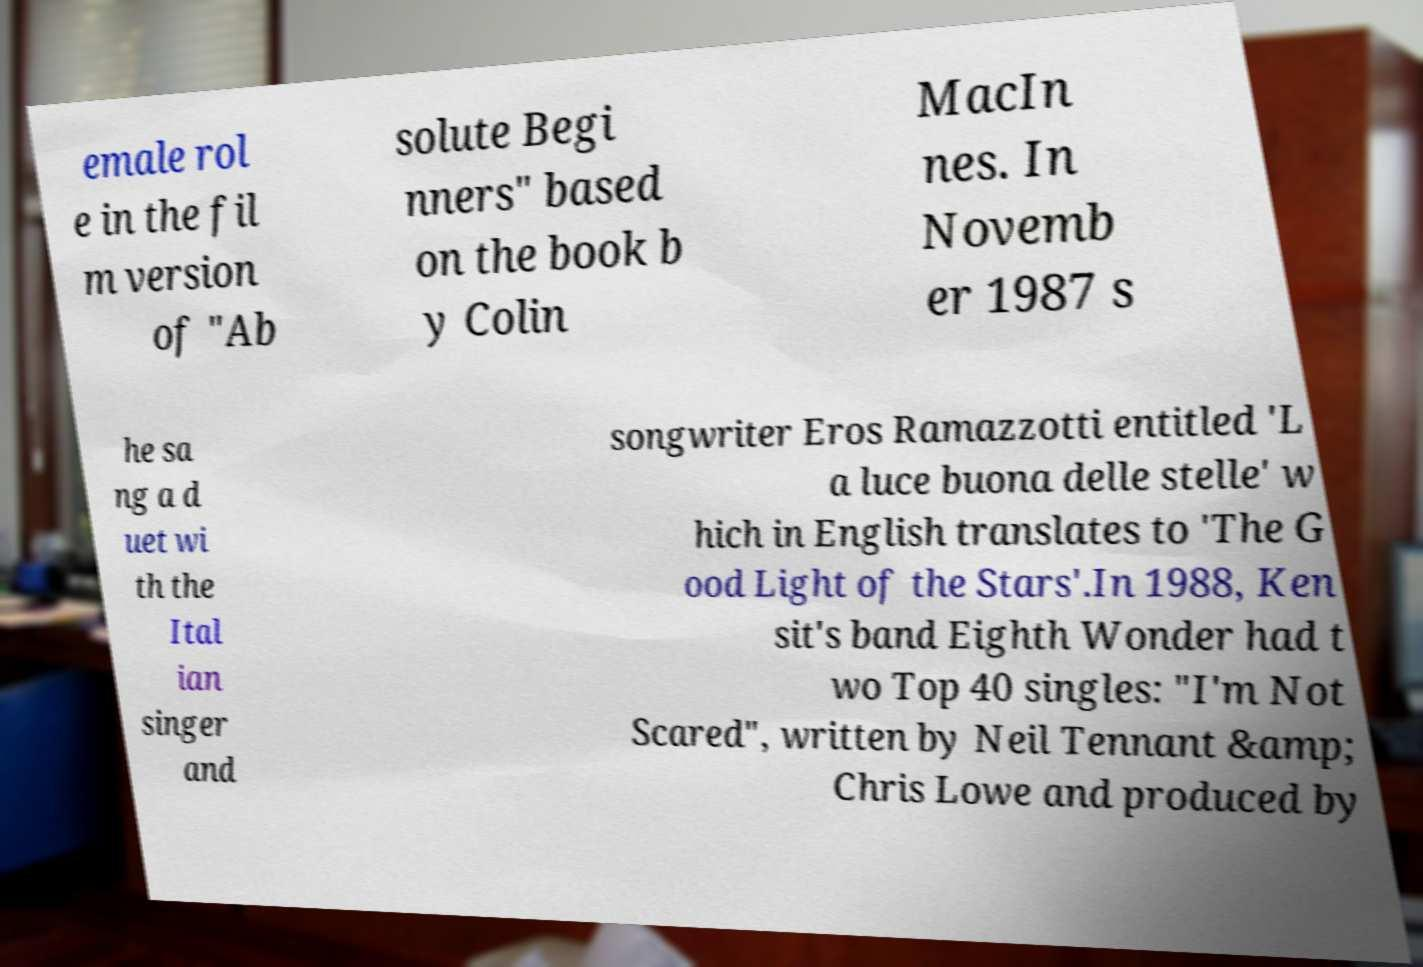I need the written content from this picture converted into text. Can you do that? emale rol e in the fil m version of "Ab solute Begi nners" based on the book b y Colin MacIn nes. In Novemb er 1987 s he sa ng a d uet wi th the Ital ian singer and songwriter Eros Ramazzotti entitled 'L a luce buona delle stelle' w hich in English translates to 'The G ood Light of the Stars'.In 1988, Ken sit's band Eighth Wonder had t wo Top 40 singles: "I'm Not Scared", written by Neil Tennant &amp; Chris Lowe and produced by 